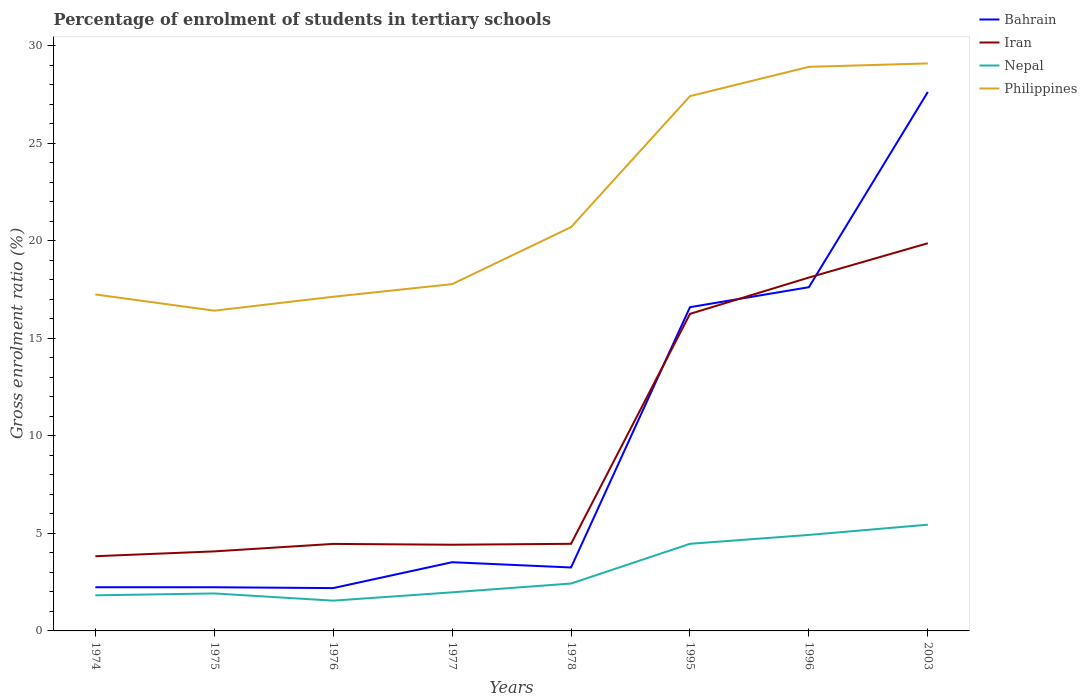Is the number of lines equal to the number of legend labels?
Make the answer very short. Yes. Across all years, what is the maximum percentage of students enrolled in tertiary schools in Philippines?
Your response must be concise. 16.42. In which year was the percentage of students enrolled in tertiary schools in Iran maximum?
Offer a very short reply. 1974. What is the total percentage of students enrolled in tertiary schools in Bahrain in the graph?
Offer a very short reply. -13.34. What is the difference between the highest and the second highest percentage of students enrolled in tertiary schools in Bahrain?
Make the answer very short. 25.43. Is the percentage of students enrolled in tertiary schools in Nepal strictly greater than the percentage of students enrolled in tertiary schools in Philippines over the years?
Ensure brevity in your answer.  Yes. How many lines are there?
Your answer should be compact. 4. Are the values on the major ticks of Y-axis written in scientific E-notation?
Offer a very short reply. No. Does the graph contain any zero values?
Keep it short and to the point. No. Where does the legend appear in the graph?
Provide a succinct answer. Top right. How many legend labels are there?
Your answer should be compact. 4. What is the title of the graph?
Make the answer very short. Percentage of enrolment of students in tertiary schools. What is the Gross enrolment ratio (%) in Bahrain in 1974?
Your answer should be compact. 2.24. What is the Gross enrolment ratio (%) in Iran in 1974?
Offer a very short reply. 3.83. What is the Gross enrolment ratio (%) in Nepal in 1974?
Offer a terse response. 1.82. What is the Gross enrolment ratio (%) in Philippines in 1974?
Your answer should be compact. 17.25. What is the Gross enrolment ratio (%) of Bahrain in 1975?
Offer a very short reply. 2.24. What is the Gross enrolment ratio (%) of Iran in 1975?
Give a very brief answer. 4.08. What is the Gross enrolment ratio (%) of Nepal in 1975?
Offer a terse response. 1.92. What is the Gross enrolment ratio (%) of Philippines in 1975?
Your response must be concise. 16.42. What is the Gross enrolment ratio (%) of Bahrain in 1976?
Your answer should be very brief. 2.2. What is the Gross enrolment ratio (%) in Iran in 1976?
Keep it short and to the point. 4.46. What is the Gross enrolment ratio (%) of Nepal in 1976?
Give a very brief answer. 1.55. What is the Gross enrolment ratio (%) in Philippines in 1976?
Ensure brevity in your answer.  17.13. What is the Gross enrolment ratio (%) of Bahrain in 1977?
Your answer should be compact. 3.52. What is the Gross enrolment ratio (%) in Iran in 1977?
Your answer should be compact. 4.42. What is the Gross enrolment ratio (%) in Nepal in 1977?
Make the answer very short. 1.98. What is the Gross enrolment ratio (%) of Philippines in 1977?
Provide a succinct answer. 17.77. What is the Gross enrolment ratio (%) of Bahrain in 1978?
Your answer should be compact. 3.25. What is the Gross enrolment ratio (%) in Iran in 1978?
Give a very brief answer. 4.46. What is the Gross enrolment ratio (%) of Nepal in 1978?
Offer a terse response. 2.43. What is the Gross enrolment ratio (%) in Philippines in 1978?
Provide a succinct answer. 20.7. What is the Gross enrolment ratio (%) of Bahrain in 1995?
Your response must be concise. 16.59. What is the Gross enrolment ratio (%) of Iran in 1995?
Offer a terse response. 16.25. What is the Gross enrolment ratio (%) of Nepal in 1995?
Your answer should be very brief. 4.47. What is the Gross enrolment ratio (%) of Philippines in 1995?
Your answer should be very brief. 27.41. What is the Gross enrolment ratio (%) of Bahrain in 1996?
Give a very brief answer. 17.62. What is the Gross enrolment ratio (%) in Iran in 1996?
Your answer should be compact. 18.11. What is the Gross enrolment ratio (%) in Nepal in 1996?
Your answer should be very brief. 4.92. What is the Gross enrolment ratio (%) in Philippines in 1996?
Your answer should be very brief. 28.91. What is the Gross enrolment ratio (%) of Bahrain in 2003?
Your answer should be compact. 27.62. What is the Gross enrolment ratio (%) in Iran in 2003?
Provide a succinct answer. 19.87. What is the Gross enrolment ratio (%) of Nepal in 2003?
Make the answer very short. 5.44. What is the Gross enrolment ratio (%) of Philippines in 2003?
Provide a succinct answer. 29.09. Across all years, what is the maximum Gross enrolment ratio (%) in Bahrain?
Provide a succinct answer. 27.62. Across all years, what is the maximum Gross enrolment ratio (%) in Iran?
Your answer should be compact. 19.87. Across all years, what is the maximum Gross enrolment ratio (%) of Nepal?
Offer a terse response. 5.44. Across all years, what is the maximum Gross enrolment ratio (%) in Philippines?
Your response must be concise. 29.09. Across all years, what is the minimum Gross enrolment ratio (%) of Bahrain?
Provide a short and direct response. 2.2. Across all years, what is the minimum Gross enrolment ratio (%) in Iran?
Provide a succinct answer. 3.83. Across all years, what is the minimum Gross enrolment ratio (%) in Nepal?
Provide a short and direct response. 1.55. Across all years, what is the minimum Gross enrolment ratio (%) in Philippines?
Offer a very short reply. 16.42. What is the total Gross enrolment ratio (%) in Bahrain in the graph?
Your answer should be very brief. 75.28. What is the total Gross enrolment ratio (%) of Iran in the graph?
Provide a short and direct response. 75.48. What is the total Gross enrolment ratio (%) in Nepal in the graph?
Ensure brevity in your answer.  24.53. What is the total Gross enrolment ratio (%) of Philippines in the graph?
Give a very brief answer. 174.67. What is the difference between the Gross enrolment ratio (%) of Iran in 1974 and that in 1975?
Give a very brief answer. -0.25. What is the difference between the Gross enrolment ratio (%) in Nepal in 1974 and that in 1975?
Provide a short and direct response. -0.1. What is the difference between the Gross enrolment ratio (%) of Philippines in 1974 and that in 1975?
Provide a short and direct response. 0.83. What is the difference between the Gross enrolment ratio (%) of Bahrain in 1974 and that in 1976?
Your response must be concise. 0.04. What is the difference between the Gross enrolment ratio (%) in Iran in 1974 and that in 1976?
Give a very brief answer. -0.63. What is the difference between the Gross enrolment ratio (%) of Nepal in 1974 and that in 1976?
Keep it short and to the point. 0.27. What is the difference between the Gross enrolment ratio (%) in Philippines in 1974 and that in 1976?
Your answer should be compact. 0.12. What is the difference between the Gross enrolment ratio (%) in Bahrain in 1974 and that in 1977?
Your response must be concise. -1.28. What is the difference between the Gross enrolment ratio (%) in Iran in 1974 and that in 1977?
Provide a succinct answer. -0.59. What is the difference between the Gross enrolment ratio (%) of Nepal in 1974 and that in 1977?
Your response must be concise. -0.15. What is the difference between the Gross enrolment ratio (%) of Philippines in 1974 and that in 1977?
Your answer should be very brief. -0.53. What is the difference between the Gross enrolment ratio (%) in Bahrain in 1974 and that in 1978?
Provide a short and direct response. -1.01. What is the difference between the Gross enrolment ratio (%) in Iran in 1974 and that in 1978?
Ensure brevity in your answer.  -0.64. What is the difference between the Gross enrolment ratio (%) in Nepal in 1974 and that in 1978?
Your answer should be very brief. -0.6. What is the difference between the Gross enrolment ratio (%) of Philippines in 1974 and that in 1978?
Ensure brevity in your answer.  -3.45. What is the difference between the Gross enrolment ratio (%) in Bahrain in 1974 and that in 1995?
Offer a very short reply. -14.35. What is the difference between the Gross enrolment ratio (%) in Iran in 1974 and that in 1995?
Provide a succinct answer. -12.42. What is the difference between the Gross enrolment ratio (%) in Nepal in 1974 and that in 1995?
Provide a succinct answer. -2.64. What is the difference between the Gross enrolment ratio (%) of Philippines in 1974 and that in 1995?
Offer a terse response. -10.16. What is the difference between the Gross enrolment ratio (%) of Bahrain in 1974 and that in 1996?
Provide a succinct answer. -15.38. What is the difference between the Gross enrolment ratio (%) of Iran in 1974 and that in 1996?
Your answer should be very brief. -14.28. What is the difference between the Gross enrolment ratio (%) in Nepal in 1974 and that in 1996?
Provide a short and direct response. -3.1. What is the difference between the Gross enrolment ratio (%) in Philippines in 1974 and that in 1996?
Offer a very short reply. -11.67. What is the difference between the Gross enrolment ratio (%) in Bahrain in 1974 and that in 2003?
Your response must be concise. -25.39. What is the difference between the Gross enrolment ratio (%) in Iran in 1974 and that in 2003?
Ensure brevity in your answer.  -16.04. What is the difference between the Gross enrolment ratio (%) in Nepal in 1974 and that in 2003?
Give a very brief answer. -3.62. What is the difference between the Gross enrolment ratio (%) of Philippines in 1974 and that in 2003?
Your answer should be very brief. -11.84. What is the difference between the Gross enrolment ratio (%) of Bahrain in 1975 and that in 1976?
Offer a very short reply. 0.04. What is the difference between the Gross enrolment ratio (%) of Iran in 1975 and that in 1976?
Offer a terse response. -0.38. What is the difference between the Gross enrolment ratio (%) in Nepal in 1975 and that in 1976?
Your response must be concise. 0.37. What is the difference between the Gross enrolment ratio (%) of Philippines in 1975 and that in 1976?
Give a very brief answer. -0.71. What is the difference between the Gross enrolment ratio (%) in Bahrain in 1975 and that in 1977?
Your answer should be compact. -1.28. What is the difference between the Gross enrolment ratio (%) in Iran in 1975 and that in 1977?
Your answer should be very brief. -0.34. What is the difference between the Gross enrolment ratio (%) in Nepal in 1975 and that in 1977?
Keep it short and to the point. -0.06. What is the difference between the Gross enrolment ratio (%) in Philippines in 1975 and that in 1977?
Keep it short and to the point. -1.36. What is the difference between the Gross enrolment ratio (%) of Bahrain in 1975 and that in 1978?
Make the answer very short. -1.01. What is the difference between the Gross enrolment ratio (%) of Iran in 1975 and that in 1978?
Your response must be concise. -0.39. What is the difference between the Gross enrolment ratio (%) of Nepal in 1975 and that in 1978?
Your response must be concise. -0.51. What is the difference between the Gross enrolment ratio (%) in Philippines in 1975 and that in 1978?
Give a very brief answer. -4.28. What is the difference between the Gross enrolment ratio (%) in Bahrain in 1975 and that in 1995?
Your answer should be compact. -14.35. What is the difference between the Gross enrolment ratio (%) of Iran in 1975 and that in 1995?
Offer a terse response. -12.17. What is the difference between the Gross enrolment ratio (%) of Nepal in 1975 and that in 1995?
Your answer should be compact. -2.54. What is the difference between the Gross enrolment ratio (%) of Philippines in 1975 and that in 1995?
Offer a terse response. -10.99. What is the difference between the Gross enrolment ratio (%) in Bahrain in 1975 and that in 1996?
Make the answer very short. -15.38. What is the difference between the Gross enrolment ratio (%) of Iran in 1975 and that in 1996?
Your answer should be very brief. -14.04. What is the difference between the Gross enrolment ratio (%) of Nepal in 1975 and that in 1996?
Provide a succinct answer. -3. What is the difference between the Gross enrolment ratio (%) of Philippines in 1975 and that in 1996?
Provide a short and direct response. -12.5. What is the difference between the Gross enrolment ratio (%) in Bahrain in 1975 and that in 2003?
Provide a succinct answer. -25.39. What is the difference between the Gross enrolment ratio (%) of Iran in 1975 and that in 2003?
Your answer should be very brief. -15.79. What is the difference between the Gross enrolment ratio (%) of Nepal in 1975 and that in 2003?
Provide a succinct answer. -3.52. What is the difference between the Gross enrolment ratio (%) in Philippines in 1975 and that in 2003?
Offer a terse response. -12.67. What is the difference between the Gross enrolment ratio (%) of Bahrain in 1976 and that in 1977?
Your answer should be compact. -1.33. What is the difference between the Gross enrolment ratio (%) in Iran in 1976 and that in 1977?
Ensure brevity in your answer.  0.04. What is the difference between the Gross enrolment ratio (%) in Nepal in 1976 and that in 1977?
Offer a terse response. -0.43. What is the difference between the Gross enrolment ratio (%) of Philippines in 1976 and that in 1977?
Keep it short and to the point. -0.65. What is the difference between the Gross enrolment ratio (%) of Bahrain in 1976 and that in 1978?
Your answer should be very brief. -1.06. What is the difference between the Gross enrolment ratio (%) in Iran in 1976 and that in 1978?
Provide a short and direct response. -0.01. What is the difference between the Gross enrolment ratio (%) of Nepal in 1976 and that in 1978?
Provide a succinct answer. -0.88. What is the difference between the Gross enrolment ratio (%) of Philippines in 1976 and that in 1978?
Provide a succinct answer. -3.57. What is the difference between the Gross enrolment ratio (%) of Bahrain in 1976 and that in 1995?
Make the answer very short. -14.4. What is the difference between the Gross enrolment ratio (%) in Iran in 1976 and that in 1995?
Provide a succinct answer. -11.79. What is the difference between the Gross enrolment ratio (%) in Nepal in 1976 and that in 1995?
Your response must be concise. -2.91. What is the difference between the Gross enrolment ratio (%) in Philippines in 1976 and that in 1995?
Offer a very short reply. -10.28. What is the difference between the Gross enrolment ratio (%) of Bahrain in 1976 and that in 1996?
Provide a succinct answer. -15.42. What is the difference between the Gross enrolment ratio (%) of Iran in 1976 and that in 1996?
Provide a succinct answer. -13.65. What is the difference between the Gross enrolment ratio (%) in Nepal in 1976 and that in 1996?
Provide a succinct answer. -3.37. What is the difference between the Gross enrolment ratio (%) in Philippines in 1976 and that in 1996?
Provide a short and direct response. -11.78. What is the difference between the Gross enrolment ratio (%) in Bahrain in 1976 and that in 2003?
Offer a terse response. -25.43. What is the difference between the Gross enrolment ratio (%) of Iran in 1976 and that in 2003?
Your answer should be very brief. -15.41. What is the difference between the Gross enrolment ratio (%) in Nepal in 1976 and that in 2003?
Your answer should be compact. -3.89. What is the difference between the Gross enrolment ratio (%) of Philippines in 1976 and that in 2003?
Your answer should be compact. -11.96. What is the difference between the Gross enrolment ratio (%) in Bahrain in 1977 and that in 1978?
Your answer should be very brief. 0.27. What is the difference between the Gross enrolment ratio (%) in Iran in 1977 and that in 1978?
Ensure brevity in your answer.  -0.05. What is the difference between the Gross enrolment ratio (%) of Nepal in 1977 and that in 1978?
Your answer should be compact. -0.45. What is the difference between the Gross enrolment ratio (%) in Philippines in 1977 and that in 1978?
Your answer should be compact. -2.92. What is the difference between the Gross enrolment ratio (%) of Bahrain in 1977 and that in 1995?
Your answer should be compact. -13.07. What is the difference between the Gross enrolment ratio (%) of Iran in 1977 and that in 1995?
Make the answer very short. -11.83. What is the difference between the Gross enrolment ratio (%) in Nepal in 1977 and that in 1995?
Give a very brief answer. -2.49. What is the difference between the Gross enrolment ratio (%) in Philippines in 1977 and that in 1995?
Keep it short and to the point. -9.63. What is the difference between the Gross enrolment ratio (%) in Bahrain in 1977 and that in 1996?
Offer a terse response. -14.1. What is the difference between the Gross enrolment ratio (%) in Iran in 1977 and that in 1996?
Provide a short and direct response. -13.7. What is the difference between the Gross enrolment ratio (%) in Nepal in 1977 and that in 1996?
Offer a terse response. -2.94. What is the difference between the Gross enrolment ratio (%) of Philippines in 1977 and that in 1996?
Give a very brief answer. -11.14. What is the difference between the Gross enrolment ratio (%) in Bahrain in 1977 and that in 2003?
Keep it short and to the point. -24.1. What is the difference between the Gross enrolment ratio (%) in Iran in 1977 and that in 2003?
Offer a very short reply. -15.45. What is the difference between the Gross enrolment ratio (%) of Nepal in 1977 and that in 2003?
Offer a very short reply. -3.47. What is the difference between the Gross enrolment ratio (%) in Philippines in 1977 and that in 2003?
Your response must be concise. -11.31. What is the difference between the Gross enrolment ratio (%) of Bahrain in 1978 and that in 1995?
Give a very brief answer. -13.34. What is the difference between the Gross enrolment ratio (%) of Iran in 1978 and that in 1995?
Offer a terse response. -11.78. What is the difference between the Gross enrolment ratio (%) of Nepal in 1978 and that in 1995?
Keep it short and to the point. -2.04. What is the difference between the Gross enrolment ratio (%) in Philippines in 1978 and that in 1995?
Keep it short and to the point. -6.71. What is the difference between the Gross enrolment ratio (%) of Bahrain in 1978 and that in 1996?
Offer a terse response. -14.37. What is the difference between the Gross enrolment ratio (%) in Iran in 1978 and that in 1996?
Your answer should be compact. -13.65. What is the difference between the Gross enrolment ratio (%) in Nepal in 1978 and that in 1996?
Give a very brief answer. -2.49. What is the difference between the Gross enrolment ratio (%) of Philippines in 1978 and that in 1996?
Your answer should be very brief. -8.22. What is the difference between the Gross enrolment ratio (%) of Bahrain in 1978 and that in 2003?
Ensure brevity in your answer.  -24.37. What is the difference between the Gross enrolment ratio (%) in Iran in 1978 and that in 2003?
Your response must be concise. -15.41. What is the difference between the Gross enrolment ratio (%) of Nepal in 1978 and that in 2003?
Offer a terse response. -3.02. What is the difference between the Gross enrolment ratio (%) in Philippines in 1978 and that in 2003?
Your response must be concise. -8.39. What is the difference between the Gross enrolment ratio (%) of Bahrain in 1995 and that in 1996?
Offer a very short reply. -1.02. What is the difference between the Gross enrolment ratio (%) in Iran in 1995 and that in 1996?
Provide a succinct answer. -1.86. What is the difference between the Gross enrolment ratio (%) in Nepal in 1995 and that in 1996?
Your answer should be very brief. -0.46. What is the difference between the Gross enrolment ratio (%) in Philippines in 1995 and that in 1996?
Keep it short and to the point. -1.5. What is the difference between the Gross enrolment ratio (%) in Bahrain in 1995 and that in 2003?
Provide a succinct answer. -11.03. What is the difference between the Gross enrolment ratio (%) in Iran in 1995 and that in 2003?
Provide a succinct answer. -3.62. What is the difference between the Gross enrolment ratio (%) of Nepal in 1995 and that in 2003?
Ensure brevity in your answer.  -0.98. What is the difference between the Gross enrolment ratio (%) of Philippines in 1995 and that in 2003?
Keep it short and to the point. -1.68. What is the difference between the Gross enrolment ratio (%) of Bahrain in 1996 and that in 2003?
Your answer should be compact. -10.01. What is the difference between the Gross enrolment ratio (%) in Iran in 1996 and that in 2003?
Your answer should be compact. -1.76. What is the difference between the Gross enrolment ratio (%) of Nepal in 1996 and that in 2003?
Give a very brief answer. -0.52. What is the difference between the Gross enrolment ratio (%) in Philippines in 1996 and that in 2003?
Your answer should be very brief. -0.17. What is the difference between the Gross enrolment ratio (%) of Bahrain in 1974 and the Gross enrolment ratio (%) of Iran in 1975?
Provide a short and direct response. -1.84. What is the difference between the Gross enrolment ratio (%) in Bahrain in 1974 and the Gross enrolment ratio (%) in Nepal in 1975?
Give a very brief answer. 0.32. What is the difference between the Gross enrolment ratio (%) in Bahrain in 1974 and the Gross enrolment ratio (%) in Philippines in 1975?
Ensure brevity in your answer.  -14.18. What is the difference between the Gross enrolment ratio (%) of Iran in 1974 and the Gross enrolment ratio (%) of Nepal in 1975?
Offer a very short reply. 1.91. What is the difference between the Gross enrolment ratio (%) of Iran in 1974 and the Gross enrolment ratio (%) of Philippines in 1975?
Your answer should be very brief. -12.59. What is the difference between the Gross enrolment ratio (%) of Nepal in 1974 and the Gross enrolment ratio (%) of Philippines in 1975?
Make the answer very short. -14.59. What is the difference between the Gross enrolment ratio (%) in Bahrain in 1974 and the Gross enrolment ratio (%) in Iran in 1976?
Keep it short and to the point. -2.22. What is the difference between the Gross enrolment ratio (%) in Bahrain in 1974 and the Gross enrolment ratio (%) in Nepal in 1976?
Give a very brief answer. 0.69. What is the difference between the Gross enrolment ratio (%) in Bahrain in 1974 and the Gross enrolment ratio (%) in Philippines in 1976?
Provide a succinct answer. -14.89. What is the difference between the Gross enrolment ratio (%) of Iran in 1974 and the Gross enrolment ratio (%) of Nepal in 1976?
Your answer should be very brief. 2.28. What is the difference between the Gross enrolment ratio (%) in Iran in 1974 and the Gross enrolment ratio (%) in Philippines in 1976?
Give a very brief answer. -13.3. What is the difference between the Gross enrolment ratio (%) of Nepal in 1974 and the Gross enrolment ratio (%) of Philippines in 1976?
Provide a succinct answer. -15.3. What is the difference between the Gross enrolment ratio (%) in Bahrain in 1974 and the Gross enrolment ratio (%) in Iran in 1977?
Offer a very short reply. -2.18. What is the difference between the Gross enrolment ratio (%) of Bahrain in 1974 and the Gross enrolment ratio (%) of Nepal in 1977?
Provide a short and direct response. 0.26. What is the difference between the Gross enrolment ratio (%) of Bahrain in 1974 and the Gross enrolment ratio (%) of Philippines in 1977?
Offer a terse response. -15.54. What is the difference between the Gross enrolment ratio (%) of Iran in 1974 and the Gross enrolment ratio (%) of Nepal in 1977?
Offer a very short reply. 1.85. What is the difference between the Gross enrolment ratio (%) in Iran in 1974 and the Gross enrolment ratio (%) in Philippines in 1977?
Make the answer very short. -13.95. What is the difference between the Gross enrolment ratio (%) in Nepal in 1974 and the Gross enrolment ratio (%) in Philippines in 1977?
Give a very brief answer. -15.95. What is the difference between the Gross enrolment ratio (%) in Bahrain in 1974 and the Gross enrolment ratio (%) in Iran in 1978?
Make the answer very short. -2.23. What is the difference between the Gross enrolment ratio (%) of Bahrain in 1974 and the Gross enrolment ratio (%) of Nepal in 1978?
Ensure brevity in your answer.  -0.19. What is the difference between the Gross enrolment ratio (%) of Bahrain in 1974 and the Gross enrolment ratio (%) of Philippines in 1978?
Offer a very short reply. -18.46. What is the difference between the Gross enrolment ratio (%) of Iran in 1974 and the Gross enrolment ratio (%) of Nepal in 1978?
Your answer should be compact. 1.4. What is the difference between the Gross enrolment ratio (%) of Iran in 1974 and the Gross enrolment ratio (%) of Philippines in 1978?
Make the answer very short. -16.87. What is the difference between the Gross enrolment ratio (%) of Nepal in 1974 and the Gross enrolment ratio (%) of Philippines in 1978?
Your answer should be compact. -18.87. What is the difference between the Gross enrolment ratio (%) of Bahrain in 1974 and the Gross enrolment ratio (%) of Iran in 1995?
Keep it short and to the point. -14.01. What is the difference between the Gross enrolment ratio (%) of Bahrain in 1974 and the Gross enrolment ratio (%) of Nepal in 1995?
Your response must be concise. -2.23. What is the difference between the Gross enrolment ratio (%) of Bahrain in 1974 and the Gross enrolment ratio (%) of Philippines in 1995?
Provide a short and direct response. -25.17. What is the difference between the Gross enrolment ratio (%) in Iran in 1974 and the Gross enrolment ratio (%) in Nepal in 1995?
Offer a terse response. -0.64. What is the difference between the Gross enrolment ratio (%) in Iran in 1974 and the Gross enrolment ratio (%) in Philippines in 1995?
Offer a very short reply. -23.58. What is the difference between the Gross enrolment ratio (%) in Nepal in 1974 and the Gross enrolment ratio (%) in Philippines in 1995?
Keep it short and to the point. -25.59. What is the difference between the Gross enrolment ratio (%) of Bahrain in 1974 and the Gross enrolment ratio (%) of Iran in 1996?
Provide a short and direct response. -15.87. What is the difference between the Gross enrolment ratio (%) in Bahrain in 1974 and the Gross enrolment ratio (%) in Nepal in 1996?
Offer a terse response. -2.68. What is the difference between the Gross enrolment ratio (%) of Bahrain in 1974 and the Gross enrolment ratio (%) of Philippines in 1996?
Your response must be concise. -26.67. What is the difference between the Gross enrolment ratio (%) in Iran in 1974 and the Gross enrolment ratio (%) in Nepal in 1996?
Offer a terse response. -1.09. What is the difference between the Gross enrolment ratio (%) in Iran in 1974 and the Gross enrolment ratio (%) in Philippines in 1996?
Ensure brevity in your answer.  -25.08. What is the difference between the Gross enrolment ratio (%) in Nepal in 1974 and the Gross enrolment ratio (%) in Philippines in 1996?
Ensure brevity in your answer.  -27.09. What is the difference between the Gross enrolment ratio (%) in Bahrain in 1974 and the Gross enrolment ratio (%) in Iran in 2003?
Give a very brief answer. -17.63. What is the difference between the Gross enrolment ratio (%) in Bahrain in 1974 and the Gross enrolment ratio (%) in Nepal in 2003?
Your answer should be very brief. -3.21. What is the difference between the Gross enrolment ratio (%) of Bahrain in 1974 and the Gross enrolment ratio (%) of Philippines in 2003?
Ensure brevity in your answer.  -26.85. What is the difference between the Gross enrolment ratio (%) in Iran in 1974 and the Gross enrolment ratio (%) in Nepal in 2003?
Your answer should be compact. -1.62. What is the difference between the Gross enrolment ratio (%) of Iran in 1974 and the Gross enrolment ratio (%) of Philippines in 2003?
Your answer should be compact. -25.26. What is the difference between the Gross enrolment ratio (%) of Nepal in 1974 and the Gross enrolment ratio (%) of Philippines in 2003?
Your answer should be very brief. -27.26. What is the difference between the Gross enrolment ratio (%) in Bahrain in 1975 and the Gross enrolment ratio (%) in Iran in 1976?
Keep it short and to the point. -2.22. What is the difference between the Gross enrolment ratio (%) in Bahrain in 1975 and the Gross enrolment ratio (%) in Nepal in 1976?
Keep it short and to the point. 0.69. What is the difference between the Gross enrolment ratio (%) in Bahrain in 1975 and the Gross enrolment ratio (%) in Philippines in 1976?
Offer a very short reply. -14.89. What is the difference between the Gross enrolment ratio (%) of Iran in 1975 and the Gross enrolment ratio (%) of Nepal in 1976?
Your answer should be very brief. 2.53. What is the difference between the Gross enrolment ratio (%) of Iran in 1975 and the Gross enrolment ratio (%) of Philippines in 1976?
Offer a terse response. -13.05. What is the difference between the Gross enrolment ratio (%) in Nepal in 1975 and the Gross enrolment ratio (%) in Philippines in 1976?
Provide a short and direct response. -15.21. What is the difference between the Gross enrolment ratio (%) of Bahrain in 1975 and the Gross enrolment ratio (%) of Iran in 1977?
Ensure brevity in your answer.  -2.18. What is the difference between the Gross enrolment ratio (%) of Bahrain in 1975 and the Gross enrolment ratio (%) of Nepal in 1977?
Give a very brief answer. 0.26. What is the difference between the Gross enrolment ratio (%) of Bahrain in 1975 and the Gross enrolment ratio (%) of Philippines in 1977?
Provide a short and direct response. -15.54. What is the difference between the Gross enrolment ratio (%) of Iran in 1975 and the Gross enrolment ratio (%) of Nepal in 1977?
Offer a terse response. 2.1. What is the difference between the Gross enrolment ratio (%) in Iran in 1975 and the Gross enrolment ratio (%) in Philippines in 1977?
Offer a very short reply. -13.7. What is the difference between the Gross enrolment ratio (%) in Nepal in 1975 and the Gross enrolment ratio (%) in Philippines in 1977?
Offer a very short reply. -15.85. What is the difference between the Gross enrolment ratio (%) of Bahrain in 1975 and the Gross enrolment ratio (%) of Iran in 1978?
Your answer should be very brief. -2.23. What is the difference between the Gross enrolment ratio (%) in Bahrain in 1975 and the Gross enrolment ratio (%) in Nepal in 1978?
Offer a terse response. -0.19. What is the difference between the Gross enrolment ratio (%) in Bahrain in 1975 and the Gross enrolment ratio (%) in Philippines in 1978?
Your answer should be compact. -18.46. What is the difference between the Gross enrolment ratio (%) of Iran in 1975 and the Gross enrolment ratio (%) of Nepal in 1978?
Your response must be concise. 1.65. What is the difference between the Gross enrolment ratio (%) of Iran in 1975 and the Gross enrolment ratio (%) of Philippines in 1978?
Your answer should be compact. -16.62. What is the difference between the Gross enrolment ratio (%) in Nepal in 1975 and the Gross enrolment ratio (%) in Philippines in 1978?
Offer a terse response. -18.78. What is the difference between the Gross enrolment ratio (%) in Bahrain in 1975 and the Gross enrolment ratio (%) in Iran in 1995?
Make the answer very short. -14.01. What is the difference between the Gross enrolment ratio (%) of Bahrain in 1975 and the Gross enrolment ratio (%) of Nepal in 1995?
Provide a short and direct response. -2.23. What is the difference between the Gross enrolment ratio (%) in Bahrain in 1975 and the Gross enrolment ratio (%) in Philippines in 1995?
Offer a terse response. -25.17. What is the difference between the Gross enrolment ratio (%) in Iran in 1975 and the Gross enrolment ratio (%) in Nepal in 1995?
Make the answer very short. -0.39. What is the difference between the Gross enrolment ratio (%) in Iran in 1975 and the Gross enrolment ratio (%) in Philippines in 1995?
Ensure brevity in your answer.  -23.33. What is the difference between the Gross enrolment ratio (%) in Nepal in 1975 and the Gross enrolment ratio (%) in Philippines in 1995?
Ensure brevity in your answer.  -25.49. What is the difference between the Gross enrolment ratio (%) of Bahrain in 1975 and the Gross enrolment ratio (%) of Iran in 1996?
Give a very brief answer. -15.87. What is the difference between the Gross enrolment ratio (%) in Bahrain in 1975 and the Gross enrolment ratio (%) in Nepal in 1996?
Keep it short and to the point. -2.68. What is the difference between the Gross enrolment ratio (%) in Bahrain in 1975 and the Gross enrolment ratio (%) in Philippines in 1996?
Give a very brief answer. -26.67. What is the difference between the Gross enrolment ratio (%) of Iran in 1975 and the Gross enrolment ratio (%) of Nepal in 1996?
Provide a short and direct response. -0.84. What is the difference between the Gross enrolment ratio (%) in Iran in 1975 and the Gross enrolment ratio (%) in Philippines in 1996?
Give a very brief answer. -24.84. What is the difference between the Gross enrolment ratio (%) of Nepal in 1975 and the Gross enrolment ratio (%) of Philippines in 1996?
Keep it short and to the point. -26.99. What is the difference between the Gross enrolment ratio (%) of Bahrain in 1975 and the Gross enrolment ratio (%) of Iran in 2003?
Provide a short and direct response. -17.63. What is the difference between the Gross enrolment ratio (%) of Bahrain in 1975 and the Gross enrolment ratio (%) of Nepal in 2003?
Your answer should be compact. -3.21. What is the difference between the Gross enrolment ratio (%) in Bahrain in 1975 and the Gross enrolment ratio (%) in Philippines in 2003?
Ensure brevity in your answer.  -26.85. What is the difference between the Gross enrolment ratio (%) of Iran in 1975 and the Gross enrolment ratio (%) of Nepal in 2003?
Your answer should be very brief. -1.37. What is the difference between the Gross enrolment ratio (%) of Iran in 1975 and the Gross enrolment ratio (%) of Philippines in 2003?
Offer a terse response. -25.01. What is the difference between the Gross enrolment ratio (%) of Nepal in 1975 and the Gross enrolment ratio (%) of Philippines in 2003?
Your response must be concise. -27.17. What is the difference between the Gross enrolment ratio (%) in Bahrain in 1976 and the Gross enrolment ratio (%) in Iran in 1977?
Keep it short and to the point. -2.22. What is the difference between the Gross enrolment ratio (%) of Bahrain in 1976 and the Gross enrolment ratio (%) of Nepal in 1977?
Offer a terse response. 0.22. What is the difference between the Gross enrolment ratio (%) of Bahrain in 1976 and the Gross enrolment ratio (%) of Philippines in 1977?
Your answer should be very brief. -15.58. What is the difference between the Gross enrolment ratio (%) of Iran in 1976 and the Gross enrolment ratio (%) of Nepal in 1977?
Your answer should be very brief. 2.48. What is the difference between the Gross enrolment ratio (%) in Iran in 1976 and the Gross enrolment ratio (%) in Philippines in 1977?
Ensure brevity in your answer.  -13.32. What is the difference between the Gross enrolment ratio (%) of Nepal in 1976 and the Gross enrolment ratio (%) of Philippines in 1977?
Give a very brief answer. -16.22. What is the difference between the Gross enrolment ratio (%) in Bahrain in 1976 and the Gross enrolment ratio (%) in Iran in 1978?
Provide a succinct answer. -2.27. What is the difference between the Gross enrolment ratio (%) of Bahrain in 1976 and the Gross enrolment ratio (%) of Nepal in 1978?
Provide a short and direct response. -0.23. What is the difference between the Gross enrolment ratio (%) in Bahrain in 1976 and the Gross enrolment ratio (%) in Philippines in 1978?
Your answer should be compact. -18.5. What is the difference between the Gross enrolment ratio (%) of Iran in 1976 and the Gross enrolment ratio (%) of Nepal in 1978?
Offer a very short reply. 2.03. What is the difference between the Gross enrolment ratio (%) in Iran in 1976 and the Gross enrolment ratio (%) in Philippines in 1978?
Offer a terse response. -16.24. What is the difference between the Gross enrolment ratio (%) of Nepal in 1976 and the Gross enrolment ratio (%) of Philippines in 1978?
Keep it short and to the point. -19.15. What is the difference between the Gross enrolment ratio (%) of Bahrain in 1976 and the Gross enrolment ratio (%) of Iran in 1995?
Offer a terse response. -14.05. What is the difference between the Gross enrolment ratio (%) of Bahrain in 1976 and the Gross enrolment ratio (%) of Nepal in 1995?
Give a very brief answer. -2.27. What is the difference between the Gross enrolment ratio (%) of Bahrain in 1976 and the Gross enrolment ratio (%) of Philippines in 1995?
Ensure brevity in your answer.  -25.21. What is the difference between the Gross enrolment ratio (%) of Iran in 1976 and the Gross enrolment ratio (%) of Nepal in 1995?
Your answer should be very brief. -0.01. What is the difference between the Gross enrolment ratio (%) of Iran in 1976 and the Gross enrolment ratio (%) of Philippines in 1995?
Make the answer very short. -22.95. What is the difference between the Gross enrolment ratio (%) of Nepal in 1976 and the Gross enrolment ratio (%) of Philippines in 1995?
Make the answer very short. -25.86. What is the difference between the Gross enrolment ratio (%) of Bahrain in 1976 and the Gross enrolment ratio (%) of Iran in 1996?
Offer a very short reply. -15.92. What is the difference between the Gross enrolment ratio (%) of Bahrain in 1976 and the Gross enrolment ratio (%) of Nepal in 1996?
Keep it short and to the point. -2.73. What is the difference between the Gross enrolment ratio (%) in Bahrain in 1976 and the Gross enrolment ratio (%) in Philippines in 1996?
Offer a very short reply. -26.72. What is the difference between the Gross enrolment ratio (%) in Iran in 1976 and the Gross enrolment ratio (%) in Nepal in 1996?
Offer a terse response. -0.46. What is the difference between the Gross enrolment ratio (%) of Iran in 1976 and the Gross enrolment ratio (%) of Philippines in 1996?
Give a very brief answer. -24.45. What is the difference between the Gross enrolment ratio (%) of Nepal in 1976 and the Gross enrolment ratio (%) of Philippines in 1996?
Make the answer very short. -27.36. What is the difference between the Gross enrolment ratio (%) of Bahrain in 1976 and the Gross enrolment ratio (%) of Iran in 2003?
Keep it short and to the point. -17.68. What is the difference between the Gross enrolment ratio (%) of Bahrain in 1976 and the Gross enrolment ratio (%) of Nepal in 2003?
Give a very brief answer. -3.25. What is the difference between the Gross enrolment ratio (%) in Bahrain in 1976 and the Gross enrolment ratio (%) in Philippines in 2003?
Provide a succinct answer. -26.89. What is the difference between the Gross enrolment ratio (%) in Iran in 1976 and the Gross enrolment ratio (%) in Nepal in 2003?
Offer a very short reply. -0.99. What is the difference between the Gross enrolment ratio (%) in Iran in 1976 and the Gross enrolment ratio (%) in Philippines in 2003?
Your response must be concise. -24.63. What is the difference between the Gross enrolment ratio (%) in Nepal in 1976 and the Gross enrolment ratio (%) in Philippines in 2003?
Keep it short and to the point. -27.54. What is the difference between the Gross enrolment ratio (%) of Bahrain in 1977 and the Gross enrolment ratio (%) of Iran in 1978?
Give a very brief answer. -0.94. What is the difference between the Gross enrolment ratio (%) of Bahrain in 1977 and the Gross enrolment ratio (%) of Nepal in 1978?
Provide a short and direct response. 1.09. What is the difference between the Gross enrolment ratio (%) in Bahrain in 1977 and the Gross enrolment ratio (%) in Philippines in 1978?
Offer a terse response. -17.18. What is the difference between the Gross enrolment ratio (%) in Iran in 1977 and the Gross enrolment ratio (%) in Nepal in 1978?
Make the answer very short. 1.99. What is the difference between the Gross enrolment ratio (%) in Iran in 1977 and the Gross enrolment ratio (%) in Philippines in 1978?
Your answer should be compact. -16.28. What is the difference between the Gross enrolment ratio (%) in Nepal in 1977 and the Gross enrolment ratio (%) in Philippines in 1978?
Offer a terse response. -18.72. What is the difference between the Gross enrolment ratio (%) of Bahrain in 1977 and the Gross enrolment ratio (%) of Iran in 1995?
Your answer should be compact. -12.73. What is the difference between the Gross enrolment ratio (%) of Bahrain in 1977 and the Gross enrolment ratio (%) of Nepal in 1995?
Your response must be concise. -0.94. What is the difference between the Gross enrolment ratio (%) in Bahrain in 1977 and the Gross enrolment ratio (%) in Philippines in 1995?
Give a very brief answer. -23.89. What is the difference between the Gross enrolment ratio (%) in Iran in 1977 and the Gross enrolment ratio (%) in Nepal in 1995?
Your answer should be very brief. -0.05. What is the difference between the Gross enrolment ratio (%) of Iran in 1977 and the Gross enrolment ratio (%) of Philippines in 1995?
Give a very brief answer. -22.99. What is the difference between the Gross enrolment ratio (%) in Nepal in 1977 and the Gross enrolment ratio (%) in Philippines in 1995?
Your answer should be compact. -25.43. What is the difference between the Gross enrolment ratio (%) in Bahrain in 1977 and the Gross enrolment ratio (%) in Iran in 1996?
Make the answer very short. -14.59. What is the difference between the Gross enrolment ratio (%) of Bahrain in 1977 and the Gross enrolment ratio (%) of Nepal in 1996?
Provide a short and direct response. -1.4. What is the difference between the Gross enrolment ratio (%) in Bahrain in 1977 and the Gross enrolment ratio (%) in Philippines in 1996?
Provide a succinct answer. -25.39. What is the difference between the Gross enrolment ratio (%) in Iran in 1977 and the Gross enrolment ratio (%) in Nepal in 1996?
Provide a short and direct response. -0.5. What is the difference between the Gross enrolment ratio (%) in Iran in 1977 and the Gross enrolment ratio (%) in Philippines in 1996?
Make the answer very short. -24.5. What is the difference between the Gross enrolment ratio (%) in Nepal in 1977 and the Gross enrolment ratio (%) in Philippines in 1996?
Keep it short and to the point. -26.93. What is the difference between the Gross enrolment ratio (%) in Bahrain in 1977 and the Gross enrolment ratio (%) in Iran in 2003?
Provide a succinct answer. -16.35. What is the difference between the Gross enrolment ratio (%) in Bahrain in 1977 and the Gross enrolment ratio (%) in Nepal in 2003?
Provide a short and direct response. -1.92. What is the difference between the Gross enrolment ratio (%) in Bahrain in 1977 and the Gross enrolment ratio (%) in Philippines in 2003?
Keep it short and to the point. -25.57. What is the difference between the Gross enrolment ratio (%) in Iran in 1977 and the Gross enrolment ratio (%) in Nepal in 2003?
Give a very brief answer. -1.03. What is the difference between the Gross enrolment ratio (%) of Iran in 1977 and the Gross enrolment ratio (%) of Philippines in 2003?
Your answer should be very brief. -24.67. What is the difference between the Gross enrolment ratio (%) in Nepal in 1977 and the Gross enrolment ratio (%) in Philippines in 2003?
Offer a terse response. -27.11. What is the difference between the Gross enrolment ratio (%) in Bahrain in 1978 and the Gross enrolment ratio (%) in Iran in 1995?
Your answer should be very brief. -13. What is the difference between the Gross enrolment ratio (%) in Bahrain in 1978 and the Gross enrolment ratio (%) in Nepal in 1995?
Offer a very short reply. -1.21. What is the difference between the Gross enrolment ratio (%) of Bahrain in 1978 and the Gross enrolment ratio (%) of Philippines in 1995?
Keep it short and to the point. -24.16. What is the difference between the Gross enrolment ratio (%) of Iran in 1978 and the Gross enrolment ratio (%) of Nepal in 1995?
Your answer should be very brief. -0. What is the difference between the Gross enrolment ratio (%) in Iran in 1978 and the Gross enrolment ratio (%) in Philippines in 1995?
Provide a short and direct response. -22.95. What is the difference between the Gross enrolment ratio (%) in Nepal in 1978 and the Gross enrolment ratio (%) in Philippines in 1995?
Ensure brevity in your answer.  -24.98. What is the difference between the Gross enrolment ratio (%) in Bahrain in 1978 and the Gross enrolment ratio (%) in Iran in 1996?
Your response must be concise. -14.86. What is the difference between the Gross enrolment ratio (%) of Bahrain in 1978 and the Gross enrolment ratio (%) of Nepal in 1996?
Provide a short and direct response. -1.67. What is the difference between the Gross enrolment ratio (%) in Bahrain in 1978 and the Gross enrolment ratio (%) in Philippines in 1996?
Your answer should be very brief. -25.66. What is the difference between the Gross enrolment ratio (%) of Iran in 1978 and the Gross enrolment ratio (%) of Nepal in 1996?
Your answer should be compact. -0.46. What is the difference between the Gross enrolment ratio (%) in Iran in 1978 and the Gross enrolment ratio (%) in Philippines in 1996?
Provide a short and direct response. -24.45. What is the difference between the Gross enrolment ratio (%) in Nepal in 1978 and the Gross enrolment ratio (%) in Philippines in 1996?
Your answer should be compact. -26.48. What is the difference between the Gross enrolment ratio (%) in Bahrain in 1978 and the Gross enrolment ratio (%) in Iran in 2003?
Give a very brief answer. -16.62. What is the difference between the Gross enrolment ratio (%) in Bahrain in 1978 and the Gross enrolment ratio (%) in Nepal in 2003?
Keep it short and to the point. -2.19. What is the difference between the Gross enrolment ratio (%) in Bahrain in 1978 and the Gross enrolment ratio (%) in Philippines in 2003?
Provide a short and direct response. -25.83. What is the difference between the Gross enrolment ratio (%) of Iran in 1978 and the Gross enrolment ratio (%) of Nepal in 2003?
Provide a short and direct response. -0.98. What is the difference between the Gross enrolment ratio (%) in Iran in 1978 and the Gross enrolment ratio (%) in Philippines in 2003?
Make the answer very short. -24.62. What is the difference between the Gross enrolment ratio (%) of Nepal in 1978 and the Gross enrolment ratio (%) of Philippines in 2003?
Offer a very short reply. -26.66. What is the difference between the Gross enrolment ratio (%) of Bahrain in 1995 and the Gross enrolment ratio (%) of Iran in 1996?
Ensure brevity in your answer.  -1.52. What is the difference between the Gross enrolment ratio (%) of Bahrain in 1995 and the Gross enrolment ratio (%) of Nepal in 1996?
Make the answer very short. 11.67. What is the difference between the Gross enrolment ratio (%) in Bahrain in 1995 and the Gross enrolment ratio (%) in Philippines in 1996?
Your answer should be very brief. -12.32. What is the difference between the Gross enrolment ratio (%) in Iran in 1995 and the Gross enrolment ratio (%) in Nepal in 1996?
Your answer should be very brief. 11.33. What is the difference between the Gross enrolment ratio (%) in Iran in 1995 and the Gross enrolment ratio (%) in Philippines in 1996?
Your answer should be compact. -12.66. What is the difference between the Gross enrolment ratio (%) in Nepal in 1995 and the Gross enrolment ratio (%) in Philippines in 1996?
Provide a short and direct response. -24.45. What is the difference between the Gross enrolment ratio (%) of Bahrain in 1995 and the Gross enrolment ratio (%) of Iran in 2003?
Offer a terse response. -3.28. What is the difference between the Gross enrolment ratio (%) in Bahrain in 1995 and the Gross enrolment ratio (%) in Nepal in 2003?
Offer a terse response. 11.15. What is the difference between the Gross enrolment ratio (%) of Bahrain in 1995 and the Gross enrolment ratio (%) of Philippines in 2003?
Your response must be concise. -12.49. What is the difference between the Gross enrolment ratio (%) in Iran in 1995 and the Gross enrolment ratio (%) in Nepal in 2003?
Make the answer very short. 10.8. What is the difference between the Gross enrolment ratio (%) of Iran in 1995 and the Gross enrolment ratio (%) of Philippines in 2003?
Give a very brief answer. -12.84. What is the difference between the Gross enrolment ratio (%) of Nepal in 1995 and the Gross enrolment ratio (%) of Philippines in 2003?
Your answer should be very brief. -24.62. What is the difference between the Gross enrolment ratio (%) in Bahrain in 1996 and the Gross enrolment ratio (%) in Iran in 2003?
Make the answer very short. -2.25. What is the difference between the Gross enrolment ratio (%) of Bahrain in 1996 and the Gross enrolment ratio (%) of Nepal in 2003?
Ensure brevity in your answer.  12.17. What is the difference between the Gross enrolment ratio (%) of Bahrain in 1996 and the Gross enrolment ratio (%) of Philippines in 2003?
Provide a succinct answer. -11.47. What is the difference between the Gross enrolment ratio (%) in Iran in 1996 and the Gross enrolment ratio (%) in Nepal in 2003?
Offer a terse response. 12.67. What is the difference between the Gross enrolment ratio (%) of Iran in 1996 and the Gross enrolment ratio (%) of Philippines in 2003?
Keep it short and to the point. -10.97. What is the difference between the Gross enrolment ratio (%) in Nepal in 1996 and the Gross enrolment ratio (%) in Philippines in 2003?
Keep it short and to the point. -24.17. What is the average Gross enrolment ratio (%) of Bahrain per year?
Offer a terse response. 9.41. What is the average Gross enrolment ratio (%) in Iran per year?
Your response must be concise. 9.44. What is the average Gross enrolment ratio (%) of Nepal per year?
Your response must be concise. 3.07. What is the average Gross enrolment ratio (%) in Philippines per year?
Ensure brevity in your answer.  21.83. In the year 1974, what is the difference between the Gross enrolment ratio (%) in Bahrain and Gross enrolment ratio (%) in Iran?
Offer a very short reply. -1.59. In the year 1974, what is the difference between the Gross enrolment ratio (%) of Bahrain and Gross enrolment ratio (%) of Nepal?
Your answer should be compact. 0.41. In the year 1974, what is the difference between the Gross enrolment ratio (%) in Bahrain and Gross enrolment ratio (%) in Philippines?
Your answer should be compact. -15.01. In the year 1974, what is the difference between the Gross enrolment ratio (%) in Iran and Gross enrolment ratio (%) in Nepal?
Make the answer very short. 2. In the year 1974, what is the difference between the Gross enrolment ratio (%) of Iran and Gross enrolment ratio (%) of Philippines?
Keep it short and to the point. -13.42. In the year 1974, what is the difference between the Gross enrolment ratio (%) in Nepal and Gross enrolment ratio (%) in Philippines?
Offer a very short reply. -15.42. In the year 1975, what is the difference between the Gross enrolment ratio (%) of Bahrain and Gross enrolment ratio (%) of Iran?
Make the answer very short. -1.84. In the year 1975, what is the difference between the Gross enrolment ratio (%) in Bahrain and Gross enrolment ratio (%) in Nepal?
Ensure brevity in your answer.  0.32. In the year 1975, what is the difference between the Gross enrolment ratio (%) of Bahrain and Gross enrolment ratio (%) of Philippines?
Give a very brief answer. -14.18. In the year 1975, what is the difference between the Gross enrolment ratio (%) of Iran and Gross enrolment ratio (%) of Nepal?
Give a very brief answer. 2.16. In the year 1975, what is the difference between the Gross enrolment ratio (%) of Iran and Gross enrolment ratio (%) of Philippines?
Provide a short and direct response. -12.34. In the year 1975, what is the difference between the Gross enrolment ratio (%) of Nepal and Gross enrolment ratio (%) of Philippines?
Offer a terse response. -14.49. In the year 1976, what is the difference between the Gross enrolment ratio (%) in Bahrain and Gross enrolment ratio (%) in Iran?
Your response must be concise. -2.26. In the year 1976, what is the difference between the Gross enrolment ratio (%) in Bahrain and Gross enrolment ratio (%) in Nepal?
Provide a succinct answer. 0.64. In the year 1976, what is the difference between the Gross enrolment ratio (%) in Bahrain and Gross enrolment ratio (%) in Philippines?
Offer a terse response. -14.93. In the year 1976, what is the difference between the Gross enrolment ratio (%) of Iran and Gross enrolment ratio (%) of Nepal?
Keep it short and to the point. 2.91. In the year 1976, what is the difference between the Gross enrolment ratio (%) in Iran and Gross enrolment ratio (%) in Philippines?
Your answer should be very brief. -12.67. In the year 1976, what is the difference between the Gross enrolment ratio (%) in Nepal and Gross enrolment ratio (%) in Philippines?
Keep it short and to the point. -15.58. In the year 1977, what is the difference between the Gross enrolment ratio (%) of Bahrain and Gross enrolment ratio (%) of Iran?
Offer a terse response. -0.9. In the year 1977, what is the difference between the Gross enrolment ratio (%) in Bahrain and Gross enrolment ratio (%) in Nepal?
Keep it short and to the point. 1.54. In the year 1977, what is the difference between the Gross enrolment ratio (%) in Bahrain and Gross enrolment ratio (%) in Philippines?
Offer a very short reply. -14.25. In the year 1977, what is the difference between the Gross enrolment ratio (%) of Iran and Gross enrolment ratio (%) of Nepal?
Provide a short and direct response. 2.44. In the year 1977, what is the difference between the Gross enrolment ratio (%) in Iran and Gross enrolment ratio (%) in Philippines?
Give a very brief answer. -13.36. In the year 1977, what is the difference between the Gross enrolment ratio (%) in Nepal and Gross enrolment ratio (%) in Philippines?
Make the answer very short. -15.8. In the year 1978, what is the difference between the Gross enrolment ratio (%) in Bahrain and Gross enrolment ratio (%) in Iran?
Make the answer very short. -1.21. In the year 1978, what is the difference between the Gross enrolment ratio (%) of Bahrain and Gross enrolment ratio (%) of Nepal?
Keep it short and to the point. 0.82. In the year 1978, what is the difference between the Gross enrolment ratio (%) in Bahrain and Gross enrolment ratio (%) in Philippines?
Offer a very short reply. -17.45. In the year 1978, what is the difference between the Gross enrolment ratio (%) in Iran and Gross enrolment ratio (%) in Nepal?
Keep it short and to the point. 2.04. In the year 1978, what is the difference between the Gross enrolment ratio (%) in Iran and Gross enrolment ratio (%) in Philippines?
Keep it short and to the point. -16.23. In the year 1978, what is the difference between the Gross enrolment ratio (%) in Nepal and Gross enrolment ratio (%) in Philippines?
Give a very brief answer. -18.27. In the year 1995, what is the difference between the Gross enrolment ratio (%) in Bahrain and Gross enrolment ratio (%) in Iran?
Your answer should be very brief. 0.34. In the year 1995, what is the difference between the Gross enrolment ratio (%) in Bahrain and Gross enrolment ratio (%) in Nepal?
Provide a short and direct response. 12.13. In the year 1995, what is the difference between the Gross enrolment ratio (%) in Bahrain and Gross enrolment ratio (%) in Philippines?
Provide a succinct answer. -10.82. In the year 1995, what is the difference between the Gross enrolment ratio (%) in Iran and Gross enrolment ratio (%) in Nepal?
Offer a terse response. 11.78. In the year 1995, what is the difference between the Gross enrolment ratio (%) in Iran and Gross enrolment ratio (%) in Philippines?
Give a very brief answer. -11.16. In the year 1995, what is the difference between the Gross enrolment ratio (%) of Nepal and Gross enrolment ratio (%) of Philippines?
Offer a terse response. -22.94. In the year 1996, what is the difference between the Gross enrolment ratio (%) in Bahrain and Gross enrolment ratio (%) in Iran?
Your response must be concise. -0.49. In the year 1996, what is the difference between the Gross enrolment ratio (%) in Bahrain and Gross enrolment ratio (%) in Nepal?
Provide a short and direct response. 12.7. In the year 1996, what is the difference between the Gross enrolment ratio (%) of Bahrain and Gross enrolment ratio (%) of Philippines?
Give a very brief answer. -11.29. In the year 1996, what is the difference between the Gross enrolment ratio (%) of Iran and Gross enrolment ratio (%) of Nepal?
Offer a terse response. 13.19. In the year 1996, what is the difference between the Gross enrolment ratio (%) in Iran and Gross enrolment ratio (%) in Philippines?
Provide a succinct answer. -10.8. In the year 1996, what is the difference between the Gross enrolment ratio (%) in Nepal and Gross enrolment ratio (%) in Philippines?
Make the answer very short. -23.99. In the year 2003, what is the difference between the Gross enrolment ratio (%) of Bahrain and Gross enrolment ratio (%) of Iran?
Offer a terse response. 7.75. In the year 2003, what is the difference between the Gross enrolment ratio (%) of Bahrain and Gross enrolment ratio (%) of Nepal?
Your response must be concise. 22.18. In the year 2003, what is the difference between the Gross enrolment ratio (%) of Bahrain and Gross enrolment ratio (%) of Philippines?
Provide a succinct answer. -1.46. In the year 2003, what is the difference between the Gross enrolment ratio (%) in Iran and Gross enrolment ratio (%) in Nepal?
Keep it short and to the point. 14.43. In the year 2003, what is the difference between the Gross enrolment ratio (%) of Iran and Gross enrolment ratio (%) of Philippines?
Ensure brevity in your answer.  -9.22. In the year 2003, what is the difference between the Gross enrolment ratio (%) in Nepal and Gross enrolment ratio (%) in Philippines?
Keep it short and to the point. -23.64. What is the ratio of the Gross enrolment ratio (%) of Iran in 1974 to that in 1975?
Keep it short and to the point. 0.94. What is the ratio of the Gross enrolment ratio (%) in Nepal in 1974 to that in 1975?
Provide a short and direct response. 0.95. What is the ratio of the Gross enrolment ratio (%) of Philippines in 1974 to that in 1975?
Your answer should be compact. 1.05. What is the ratio of the Gross enrolment ratio (%) of Bahrain in 1974 to that in 1976?
Your response must be concise. 1.02. What is the ratio of the Gross enrolment ratio (%) in Iran in 1974 to that in 1976?
Provide a succinct answer. 0.86. What is the ratio of the Gross enrolment ratio (%) in Nepal in 1974 to that in 1976?
Offer a terse response. 1.18. What is the ratio of the Gross enrolment ratio (%) of Philippines in 1974 to that in 1976?
Offer a very short reply. 1.01. What is the ratio of the Gross enrolment ratio (%) of Bahrain in 1974 to that in 1977?
Offer a very short reply. 0.64. What is the ratio of the Gross enrolment ratio (%) in Iran in 1974 to that in 1977?
Offer a very short reply. 0.87. What is the ratio of the Gross enrolment ratio (%) in Nepal in 1974 to that in 1977?
Keep it short and to the point. 0.92. What is the ratio of the Gross enrolment ratio (%) in Philippines in 1974 to that in 1977?
Provide a short and direct response. 0.97. What is the ratio of the Gross enrolment ratio (%) of Bahrain in 1974 to that in 1978?
Provide a succinct answer. 0.69. What is the ratio of the Gross enrolment ratio (%) of Iran in 1974 to that in 1978?
Ensure brevity in your answer.  0.86. What is the ratio of the Gross enrolment ratio (%) in Nepal in 1974 to that in 1978?
Your answer should be compact. 0.75. What is the ratio of the Gross enrolment ratio (%) in Bahrain in 1974 to that in 1995?
Ensure brevity in your answer.  0.13. What is the ratio of the Gross enrolment ratio (%) in Iran in 1974 to that in 1995?
Keep it short and to the point. 0.24. What is the ratio of the Gross enrolment ratio (%) in Nepal in 1974 to that in 1995?
Provide a short and direct response. 0.41. What is the ratio of the Gross enrolment ratio (%) of Philippines in 1974 to that in 1995?
Your answer should be very brief. 0.63. What is the ratio of the Gross enrolment ratio (%) in Bahrain in 1974 to that in 1996?
Offer a very short reply. 0.13. What is the ratio of the Gross enrolment ratio (%) of Iran in 1974 to that in 1996?
Provide a short and direct response. 0.21. What is the ratio of the Gross enrolment ratio (%) of Nepal in 1974 to that in 1996?
Provide a succinct answer. 0.37. What is the ratio of the Gross enrolment ratio (%) of Philippines in 1974 to that in 1996?
Ensure brevity in your answer.  0.6. What is the ratio of the Gross enrolment ratio (%) of Bahrain in 1974 to that in 2003?
Your response must be concise. 0.08. What is the ratio of the Gross enrolment ratio (%) in Iran in 1974 to that in 2003?
Provide a succinct answer. 0.19. What is the ratio of the Gross enrolment ratio (%) of Nepal in 1974 to that in 2003?
Make the answer very short. 0.34. What is the ratio of the Gross enrolment ratio (%) in Philippines in 1974 to that in 2003?
Give a very brief answer. 0.59. What is the ratio of the Gross enrolment ratio (%) of Bahrain in 1975 to that in 1976?
Make the answer very short. 1.02. What is the ratio of the Gross enrolment ratio (%) of Iran in 1975 to that in 1976?
Your response must be concise. 0.91. What is the ratio of the Gross enrolment ratio (%) in Nepal in 1975 to that in 1976?
Offer a terse response. 1.24. What is the ratio of the Gross enrolment ratio (%) of Philippines in 1975 to that in 1976?
Provide a succinct answer. 0.96. What is the ratio of the Gross enrolment ratio (%) in Bahrain in 1975 to that in 1977?
Your response must be concise. 0.64. What is the ratio of the Gross enrolment ratio (%) of Iran in 1975 to that in 1977?
Offer a very short reply. 0.92. What is the ratio of the Gross enrolment ratio (%) in Nepal in 1975 to that in 1977?
Give a very brief answer. 0.97. What is the ratio of the Gross enrolment ratio (%) of Philippines in 1975 to that in 1977?
Keep it short and to the point. 0.92. What is the ratio of the Gross enrolment ratio (%) of Bahrain in 1975 to that in 1978?
Offer a terse response. 0.69. What is the ratio of the Gross enrolment ratio (%) in Iran in 1975 to that in 1978?
Give a very brief answer. 0.91. What is the ratio of the Gross enrolment ratio (%) of Nepal in 1975 to that in 1978?
Your answer should be very brief. 0.79. What is the ratio of the Gross enrolment ratio (%) in Philippines in 1975 to that in 1978?
Provide a short and direct response. 0.79. What is the ratio of the Gross enrolment ratio (%) in Bahrain in 1975 to that in 1995?
Your response must be concise. 0.13. What is the ratio of the Gross enrolment ratio (%) in Iran in 1975 to that in 1995?
Keep it short and to the point. 0.25. What is the ratio of the Gross enrolment ratio (%) of Nepal in 1975 to that in 1995?
Your answer should be very brief. 0.43. What is the ratio of the Gross enrolment ratio (%) of Philippines in 1975 to that in 1995?
Your response must be concise. 0.6. What is the ratio of the Gross enrolment ratio (%) in Bahrain in 1975 to that in 1996?
Make the answer very short. 0.13. What is the ratio of the Gross enrolment ratio (%) of Iran in 1975 to that in 1996?
Offer a very short reply. 0.23. What is the ratio of the Gross enrolment ratio (%) in Nepal in 1975 to that in 1996?
Keep it short and to the point. 0.39. What is the ratio of the Gross enrolment ratio (%) in Philippines in 1975 to that in 1996?
Your response must be concise. 0.57. What is the ratio of the Gross enrolment ratio (%) in Bahrain in 1975 to that in 2003?
Ensure brevity in your answer.  0.08. What is the ratio of the Gross enrolment ratio (%) of Iran in 1975 to that in 2003?
Offer a terse response. 0.21. What is the ratio of the Gross enrolment ratio (%) in Nepal in 1975 to that in 2003?
Your answer should be very brief. 0.35. What is the ratio of the Gross enrolment ratio (%) of Philippines in 1975 to that in 2003?
Provide a succinct answer. 0.56. What is the ratio of the Gross enrolment ratio (%) in Bahrain in 1976 to that in 1977?
Your response must be concise. 0.62. What is the ratio of the Gross enrolment ratio (%) in Iran in 1976 to that in 1977?
Your answer should be very brief. 1.01. What is the ratio of the Gross enrolment ratio (%) of Nepal in 1976 to that in 1977?
Your answer should be very brief. 0.78. What is the ratio of the Gross enrolment ratio (%) in Philippines in 1976 to that in 1977?
Offer a very short reply. 0.96. What is the ratio of the Gross enrolment ratio (%) of Bahrain in 1976 to that in 1978?
Your answer should be compact. 0.68. What is the ratio of the Gross enrolment ratio (%) in Nepal in 1976 to that in 1978?
Offer a very short reply. 0.64. What is the ratio of the Gross enrolment ratio (%) of Philippines in 1976 to that in 1978?
Your answer should be very brief. 0.83. What is the ratio of the Gross enrolment ratio (%) of Bahrain in 1976 to that in 1995?
Ensure brevity in your answer.  0.13. What is the ratio of the Gross enrolment ratio (%) in Iran in 1976 to that in 1995?
Provide a succinct answer. 0.27. What is the ratio of the Gross enrolment ratio (%) in Nepal in 1976 to that in 1995?
Your answer should be very brief. 0.35. What is the ratio of the Gross enrolment ratio (%) of Philippines in 1976 to that in 1995?
Ensure brevity in your answer.  0.62. What is the ratio of the Gross enrolment ratio (%) in Bahrain in 1976 to that in 1996?
Provide a short and direct response. 0.12. What is the ratio of the Gross enrolment ratio (%) in Iran in 1976 to that in 1996?
Offer a very short reply. 0.25. What is the ratio of the Gross enrolment ratio (%) in Nepal in 1976 to that in 1996?
Offer a terse response. 0.32. What is the ratio of the Gross enrolment ratio (%) in Philippines in 1976 to that in 1996?
Your answer should be compact. 0.59. What is the ratio of the Gross enrolment ratio (%) of Bahrain in 1976 to that in 2003?
Your answer should be compact. 0.08. What is the ratio of the Gross enrolment ratio (%) in Iran in 1976 to that in 2003?
Make the answer very short. 0.22. What is the ratio of the Gross enrolment ratio (%) of Nepal in 1976 to that in 2003?
Offer a very short reply. 0.28. What is the ratio of the Gross enrolment ratio (%) in Philippines in 1976 to that in 2003?
Ensure brevity in your answer.  0.59. What is the ratio of the Gross enrolment ratio (%) of Bahrain in 1977 to that in 1978?
Your answer should be compact. 1.08. What is the ratio of the Gross enrolment ratio (%) of Iran in 1977 to that in 1978?
Make the answer very short. 0.99. What is the ratio of the Gross enrolment ratio (%) in Nepal in 1977 to that in 1978?
Your answer should be very brief. 0.81. What is the ratio of the Gross enrolment ratio (%) in Philippines in 1977 to that in 1978?
Offer a terse response. 0.86. What is the ratio of the Gross enrolment ratio (%) in Bahrain in 1977 to that in 1995?
Ensure brevity in your answer.  0.21. What is the ratio of the Gross enrolment ratio (%) of Iran in 1977 to that in 1995?
Ensure brevity in your answer.  0.27. What is the ratio of the Gross enrolment ratio (%) of Nepal in 1977 to that in 1995?
Offer a very short reply. 0.44. What is the ratio of the Gross enrolment ratio (%) of Philippines in 1977 to that in 1995?
Give a very brief answer. 0.65. What is the ratio of the Gross enrolment ratio (%) of Bahrain in 1977 to that in 1996?
Offer a very short reply. 0.2. What is the ratio of the Gross enrolment ratio (%) in Iran in 1977 to that in 1996?
Ensure brevity in your answer.  0.24. What is the ratio of the Gross enrolment ratio (%) in Nepal in 1977 to that in 1996?
Your answer should be compact. 0.4. What is the ratio of the Gross enrolment ratio (%) of Philippines in 1977 to that in 1996?
Your response must be concise. 0.61. What is the ratio of the Gross enrolment ratio (%) in Bahrain in 1977 to that in 2003?
Your response must be concise. 0.13. What is the ratio of the Gross enrolment ratio (%) in Iran in 1977 to that in 2003?
Your answer should be compact. 0.22. What is the ratio of the Gross enrolment ratio (%) in Nepal in 1977 to that in 2003?
Your response must be concise. 0.36. What is the ratio of the Gross enrolment ratio (%) in Philippines in 1977 to that in 2003?
Your answer should be very brief. 0.61. What is the ratio of the Gross enrolment ratio (%) of Bahrain in 1978 to that in 1995?
Your answer should be very brief. 0.2. What is the ratio of the Gross enrolment ratio (%) of Iran in 1978 to that in 1995?
Make the answer very short. 0.27. What is the ratio of the Gross enrolment ratio (%) of Nepal in 1978 to that in 1995?
Your answer should be compact. 0.54. What is the ratio of the Gross enrolment ratio (%) in Philippines in 1978 to that in 1995?
Make the answer very short. 0.76. What is the ratio of the Gross enrolment ratio (%) in Bahrain in 1978 to that in 1996?
Your answer should be very brief. 0.18. What is the ratio of the Gross enrolment ratio (%) in Iran in 1978 to that in 1996?
Make the answer very short. 0.25. What is the ratio of the Gross enrolment ratio (%) in Nepal in 1978 to that in 1996?
Your response must be concise. 0.49. What is the ratio of the Gross enrolment ratio (%) in Philippines in 1978 to that in 1996?
Your response must be concise. 0.72. What is the ratio of the Gross enrolment ratio (%) of Bahrain in 1978 to that in 2003?
Offer a very short reply. 0.12. What is the ratio of the Gross enrolment ratio (%) in Iran in 1978 to that in 2003?
Ensure brevity in your answer.  0.22. What is the ratio of the Gross enrolment ratio (%) of Nepal in 1978 to that in 2003?
Your answer should be very brief. 0.45. What is the ratio of the Gross enrolment ratio (%) of Philippines in 1978 to that in 2003?
Make the answer very short. 0.71. What is the ratio of the Gross enrolment ratio (%) of Bahrain in 1995 to that in 1996?
Give a very brief answer. 0.94. What is the ratio of the Gross enrolment ratio (%) of Iran in 1995 to that in 1996?
Your answer should be compact. 0.9. What is the ratio of the Gross enrolment ratio (%) of Nepal in 1995 to that in 1996?
Make the answer very short. 0.91. What is the ratio of the Gross enrolment ratio (%) of Philippines in 1995 to that in 1996?
Your answer should be very brief. 0.95. What is the ratio of the Gross enrolment ratio (%) of Bahrain in 1995 to that in 2003?
Ensure brevity in your answer.  0.6. What is the ratio of the Gross enrolment ratio (%) in Iran in 1995 to that in 2003?
Ensure brevity in your answer.  0.82. What is the ratio of the Gross enrolment ratio (%) of Nepal in 1995 to that in 2003?
Keep it short and to the point. 0.82. What is the ratio of the Gross enrolment ratio (%) of Philippines in 1995 to that in 2003?
Offer a terse response. 0.94. What is the ratio of the Gross enrolment ratio (%) of Bahrain in 1996 to that in 2003?
Your response must be concise. 0.64. What is the ratio of the Gross enrolment ratio (%) in Iran in 1996 to that in 2003?
Your response must be concise. 0.91. What is the ratio of the Gross enrolment ratio (%) in Nepal in 1996 to that in 2003?
Offer a very short reply. 0.9. What is the ratio of the Gross enrolment ratio (%) of Philippines in 1996 to that in 2003?
Provide a succinct answer. 0.99. What is the difference between the highest and the second highest Gross enrolment ratio (%) in Bahrain?
Ensure brevity in your answer.  10.01. What is the difference between the highest and the second highest Gross enrolment ratio (%) in Iran?
Ensure brevity in your answer.  1.76. What is the difference between the highest and the second highest Gross enrolment ratio (%) of Nepal?
Your answer should be very brief. 0.52. What is the difference between the highest and the second highest Gross enrolment ratio (%) in Philippines?
Offer a very short reply. 0.17. What is the difference between the highest and the lowest Gross enrolment ratio (%) in Bahrain?
Ensure brevity in your answer.  25.43. What is the difference between the highest and the lowest Gross enrolment ratio (%) of Iran?
Ensure brevity in your answer.  16.04. What is the difference between the highest and the lowest Gross enrolment ratio (%) of Nepal?
Provide a succinct answer. 3.89. What is the difference between the highest and the lowest Gross enrolment ratio (%) in Philippines?
Offer a very short reply. 12.67. 